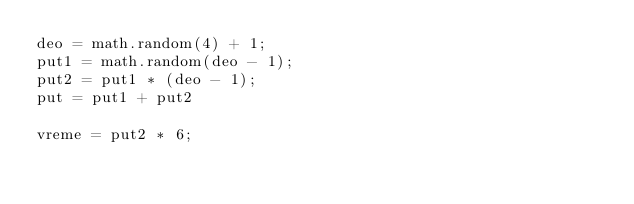Convert code to text. <code><loc_0><loc_0><loc_500><loc_500><_Lua_>deo = math.random(4) + 1;
put1 = math.random(deo - 1);
put2 = put1 * (deo - 1);
put = put1 + put2

vreme = put2 * 6; 
        
                     

                  
                     

</code> 